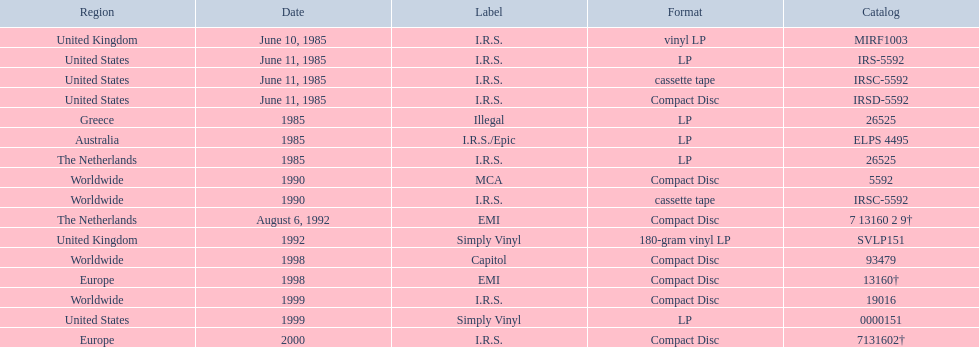Which region has more than one format? United States. 